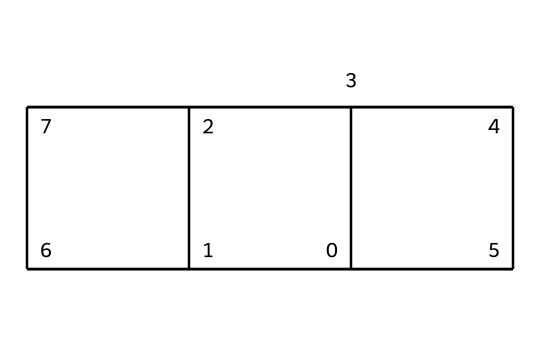How many carbon atoms are present in this compound? The SMILES notation indicates multiple carbon atoms within the structure. By analyzing the notation, we can see that 'C' appears multiple times, specifically counting up the unique instances, we find there are 8 carbon atoms in total.
Answer: 8 What is the molecular formula of cubane? The compound cubane consists of 8 carbon atoms and 8 hydrogen atoms, which can be represented as C8H8. The analysis of the rings and the bonding patterns in the structure also confirms this composition.
Answer: C8H8 What is the geometry of cubane? Cubane has a cubic geometry due to its three-dimensional arrangement of carbon atoms forming a cube, with all bond angles ideally being 90 degrees between neighboring carbon atoms.
Answer: cubic Does cubane have any double bonds? Observing the structure, we note that it consists only of single bonds linking the carbon atoms. Therefore, there are no double bonds in this compound.
Answer: no How many hydrogen atoms are bonded to each carbon in cubane? Each carbon atom in cubane is bonded to two hydrogen atoms due to its structure, which maintains saturation without forming any multiple bonds. Through an examination of the structure, this bonding configuration can be confirmed.
Answer: 2 What type of compound is cubane classified as? Cubane is an example of a cage hydrocarbon, specifically because of its closed, three-dimensional structure that resembles a cube, differentiating it from linear or branched hydrocarbons.
Answer: cage hydrocarbon What is one unique property of cubane compared to other hydrocarbons? One unique property of cubane is its high strain energy resulting from the 90-degree bond angles in its structure, which is significantly higher than that of typical aliphatic hydrocarbons. This feature can be inferred from the unusual arrangement of atoms.
Answer: high strain energy 